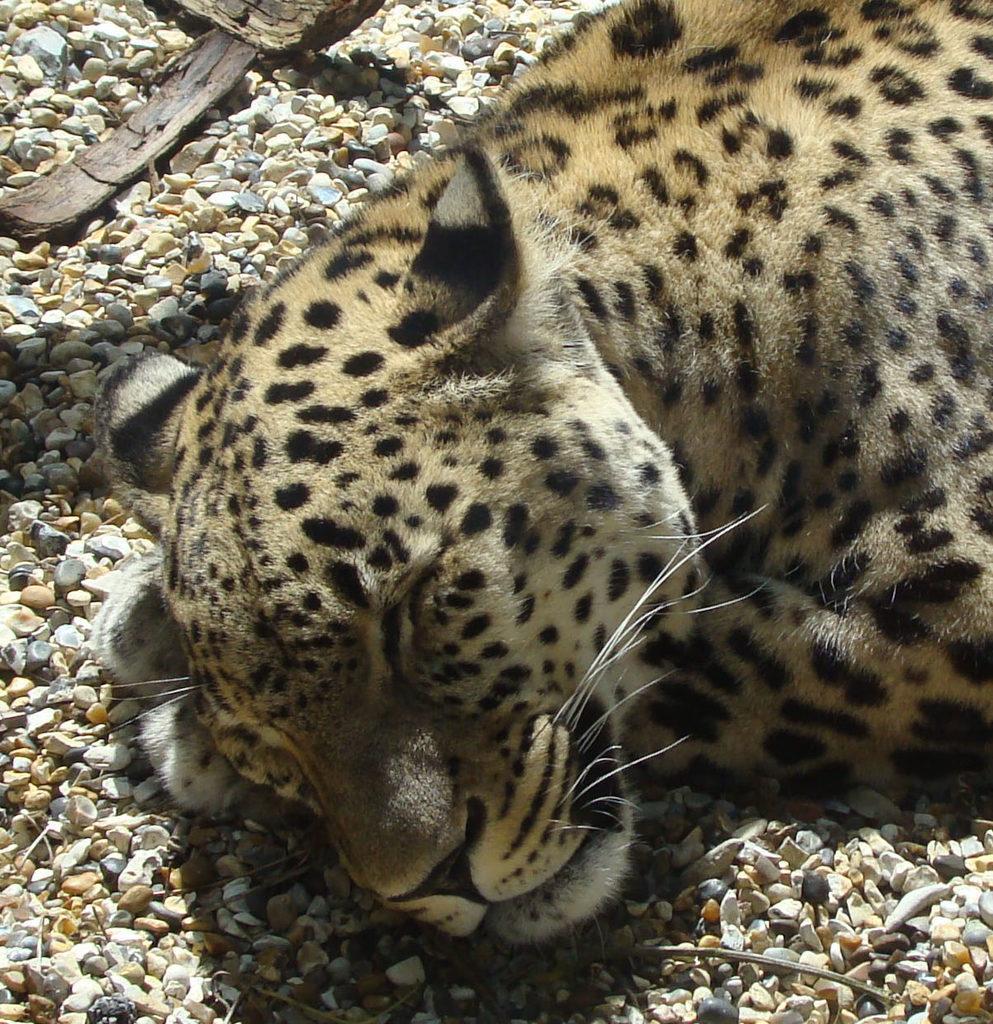How would you summarize this image in a sentence or two? In this picture we can see a leopard is sleeping, at the bottom there are some stones. 